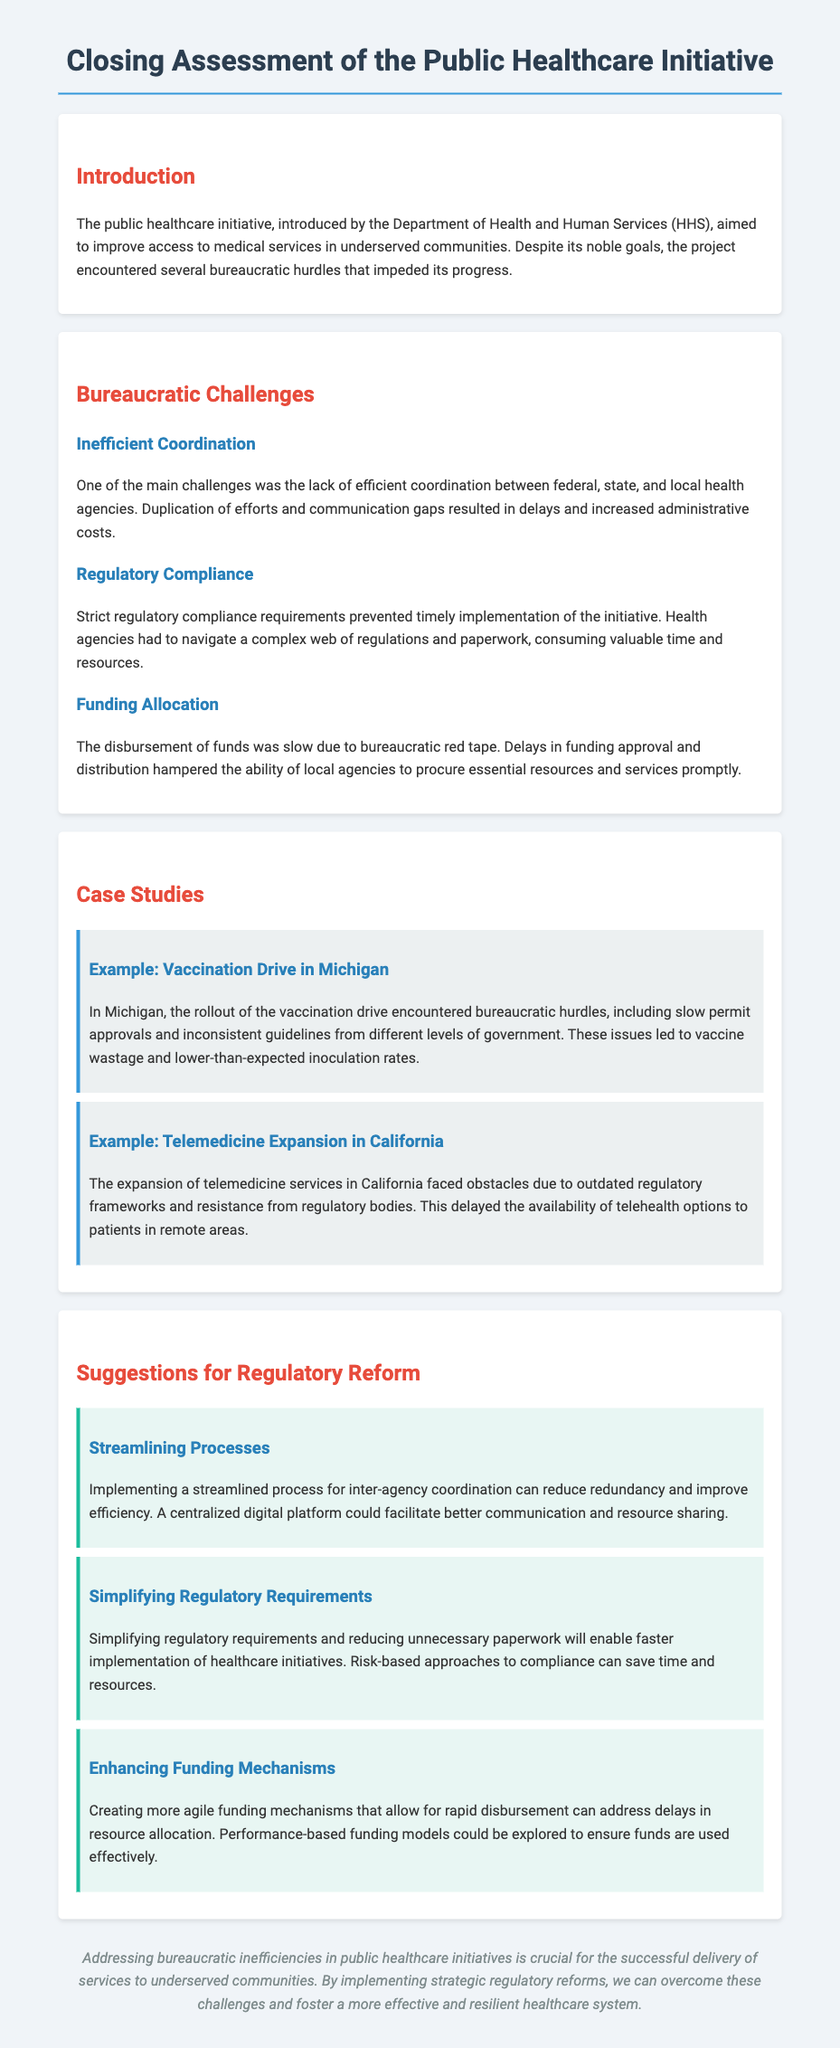What was the main aim of the public healthcare initiative? The main aim was to improve access to medical services in underserved communities.
Answer: Improve access to medical services What hindered timely implementation of the initiative? Strict regulatory compliance requirements and a complex web of regulations and paperwork hindered timely implementation.
Answer: Strict regulatory compliance What was one example of a bureaucratic hurdle in Michigan? Slow permit approvals and inconsistent guidelines from different levels of government were hurdles.
Answer: Slow permit approvals What suggestion was made for enhancing funding mechanisms? Creating more agile funding mechanisms that allow for rapid disbursement was suggested.
Answer: More agile funding mechanisms Which state faced obstacles due to outdated regulatory frameworks? California faced obstacles due to outdated regulatory frameworks.
Answer: California What was a major issue mentioned regarding funding allocation? The disbursement of funds was slow due to bureaucratic red tape.
Answer: Slow disbursement of funds What type of approach is suggested for simplifying regulatory requirements? A risk-based approach to compliance is suggested for simplifying regulatory requirements.
Answer: Risk-based approach Which health agencies were mentioned as lacking efficient coordination? Federal, state, and local health agencies were mentioned.
Answer: Federal, state, and local health agencies What is the concluding recommendation for overcoming bureaucratic challenges? Implementing strategic regulatory reforms is the concluding recommendation.
Answer: Strategic regulatory reforms 